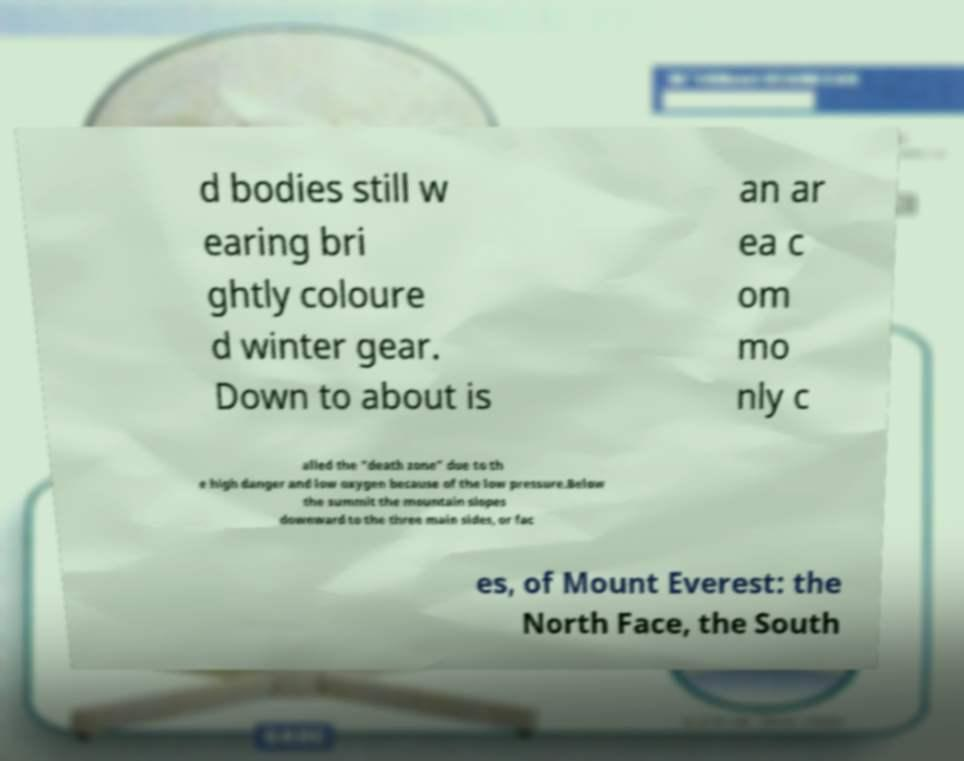I need the written content from this picture converted into text. Can you do that? d bodies still w earing bri ghtly coloure d winter gear. Down to about is an ar ea c om mo nly c alled the "death zone" due to th e high danger and low oxygen because of the low pressure.Below the summit the mountain slopes downward to the three main sides, or fac es, of Mount Everest: the North Face, the South 